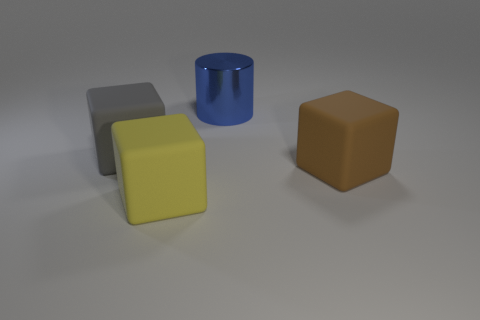Subtract all gray blocks. How many blocks are left? 2 Add 2 large brown matte blocks. How many objects exist? 6 Subtract all green blocks. Subtract all cyan spheres. How many blocks are left? 3 Subtract all cubes. How many objects are left? 1 Subtract all large brown rubber blocks. Subtract all gray objects. How many objects are left? 2 Add 1 yellow matte things. How many yellow matte things are left? 2 Add 3 large blocks. How many large blocks exist? 6 Subtract 0 cyan blocks. How many objects are left? 4 